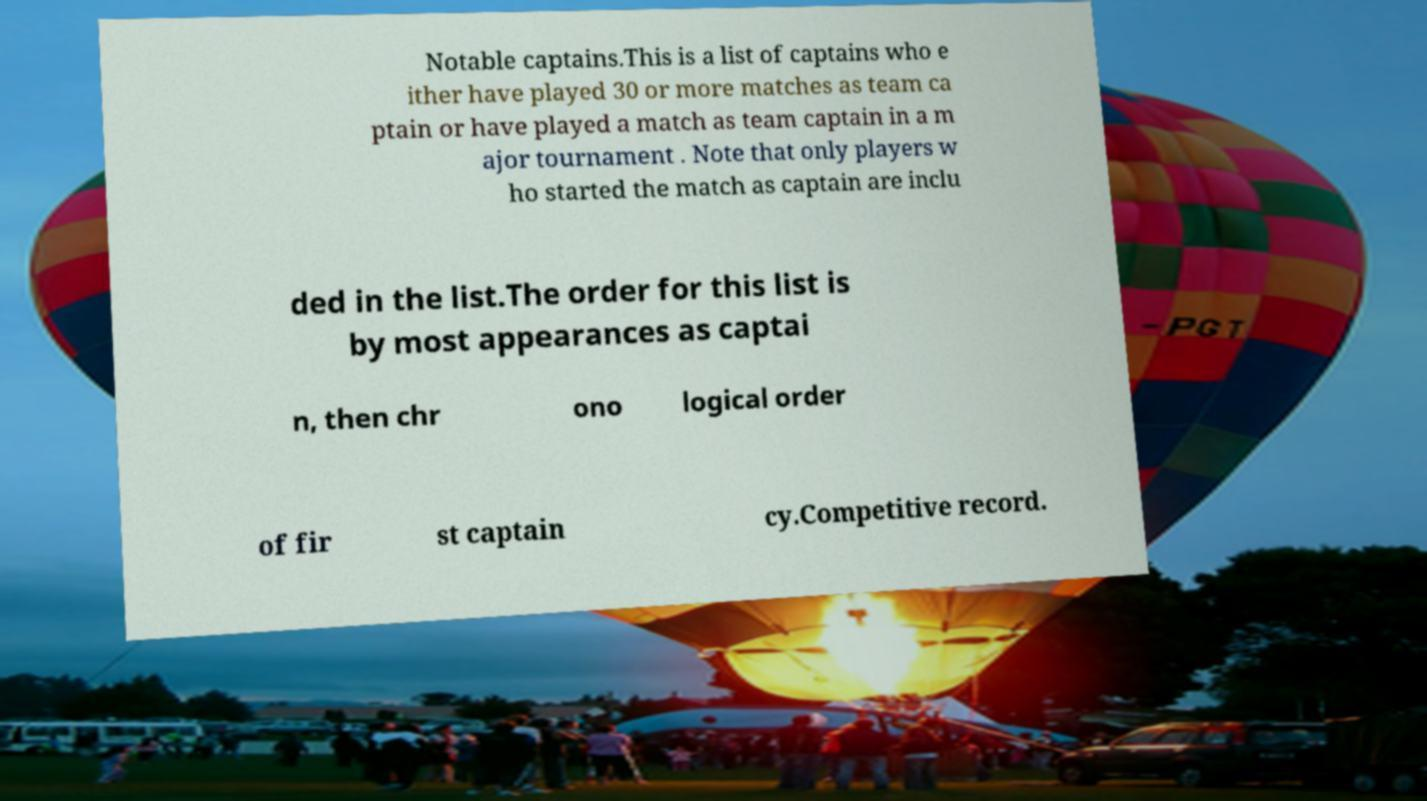Please read and relay the text visible in this image. What does it say? Notable captains.This is a list of captains who e ither have played 30 or more matches as team ca ptain or have played a match as team captain in a m ajor tournament . Note that only players w ho started the match as captain are inclu ded in the list.The order for this list is by most appearances as captai n, then chr ono logical order of fir st captain cy.Competitive record. 